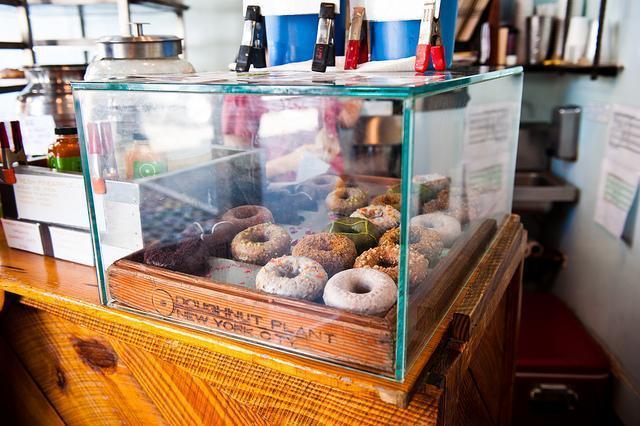How many bottles are visible?
Give a very brief answer. 2. How many donuts can be seen?
Give a very brief answer. 4. 